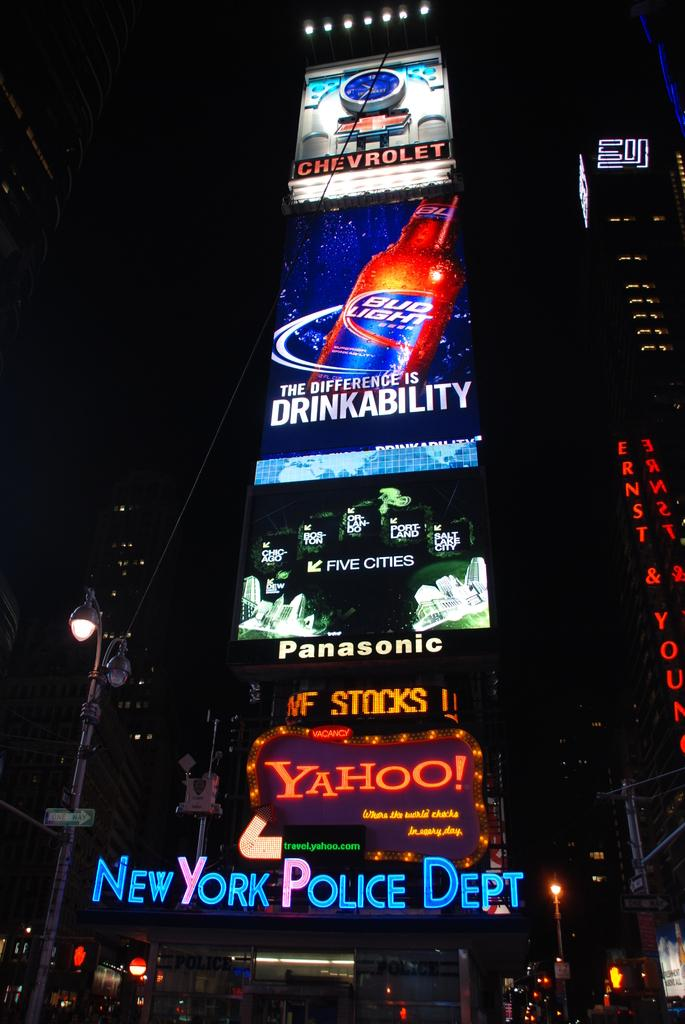<image>
Render a clear and concise summary of the photo. A series of electronic billboards hang above a sign for the New York Police Department. 